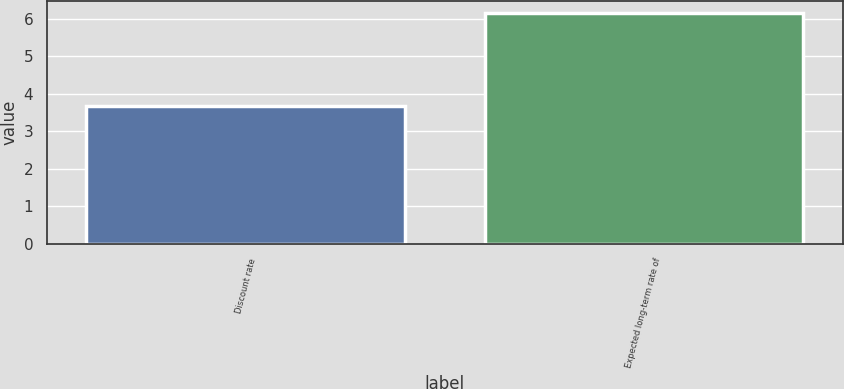Convert chart to OTSL. <chart><loc_0><loc_0><loc_500><loc_500><bar_chart><fcel>Discount rate<fcel>Expected long-term rate of<nl><fcel>3.68<fcel>6.15<nl></chart> 